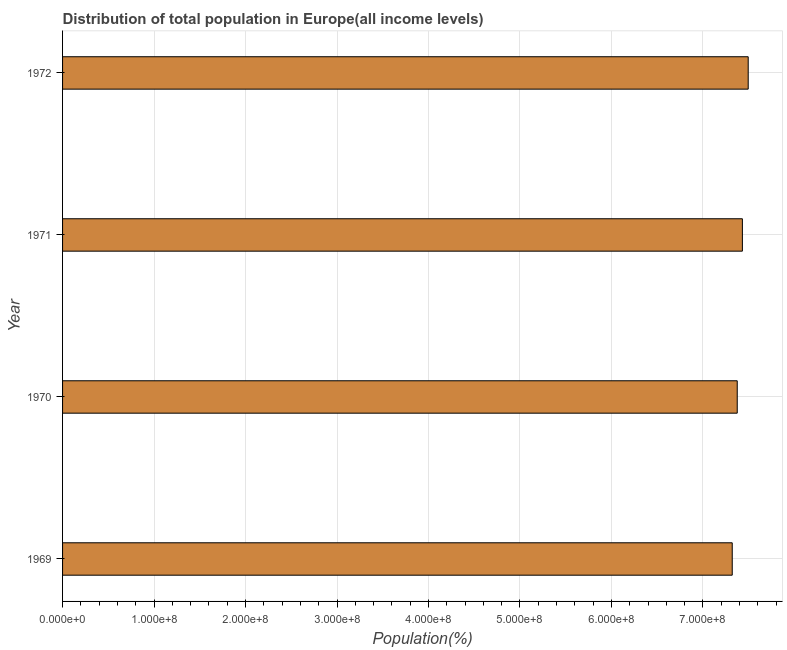Does the graph contain grids?
Give a very brief answer. Yes. What is the title of the graph?
Provide a short and direct response. Distribution of total population in Europe(all income levels) . What is the label or title of the X-axis?
Offer a very short reply. Population(%). What is the population in 1972?
Ensure brevity in your answer.  7.50e+08. Across all years, what is the maximum population?
Give a very brief answer. 7.50e+08. Across all years, what is the minimum population?
Keep it short and to the point. 7.32e+08. In which year was the population maximum?
Your response must be concise. 1972. In which year was the population minimum?
Ensure brevity in your answer.  1969. What is the sum of the population?
Provide a short and direct response. 2.96e+09. What is the difference between the population in 1969 and 1971?
Your answer should be very brief. -1.11e+07. What is the average population per year?
Make the answer very short. 7.41e+08. What is the median population?
Give a very brief answer. 7.40e+08. What is the difference between the highest and the second highest population?
Provide a short and direct response. 6.36e+06. Is the sum of the population in 1970 and 1972 greater than the maximum population across all years?
Make the answer very short. Yes. What is the difference between the highest and the lowest population?
Your answer should be compact. 1.75e+07. In how many years, is the population greater than the average population taken over all years?
Your answer should be very brief. 2. How many bars are there?
Provide a succinct answer. 4. Are all the bars in the graph horizontal?
Make the answer very short. Yes. What is the Population(%) of 1969?
Provide a short and direct response. 7.32e+08. What is the Population(%) in 1970?
Offer a terse response. 7.38e+08. What is the Population(%) of 1971?
Provide a succinct answer. 7.43e+08. What is the Population(%) in 1972?
Ensure brevity in your answer.  7.50e+08. What is the difference between the Population(%) in 1969 and 1970?
Your answer should be very brief. -5.46e+06. What is the difference between the Population(%) in 1969 and 1971?
Give a very brief answer. -1.11e+07. What is the difference between the Population(%) in 1969 and 1972?
Make the answer very short. -1.75e+07. What is the difference between the Population(%) in 1970 and 1971?
Offer a very short reply. -5.65e+06. What is the difference between the Population(%) in 1970 and 1972?
Give a very brief answer. -1.20e+07. What is the difference between the Population(%) in 1971 and 1972?
Provide a short and direct response. -6.36e+06. What is the ratio of the Population(%) in 1969 to that in 1971?
Offer a very short reply. 0.98. What is the ratio of the Population(%) in 1970 to that in 1971?
Keep it short and to the point. 0.99. What is the ratio of the Population(%) in 1970 to that in 1972?
Offer a terse response. 0.98. 